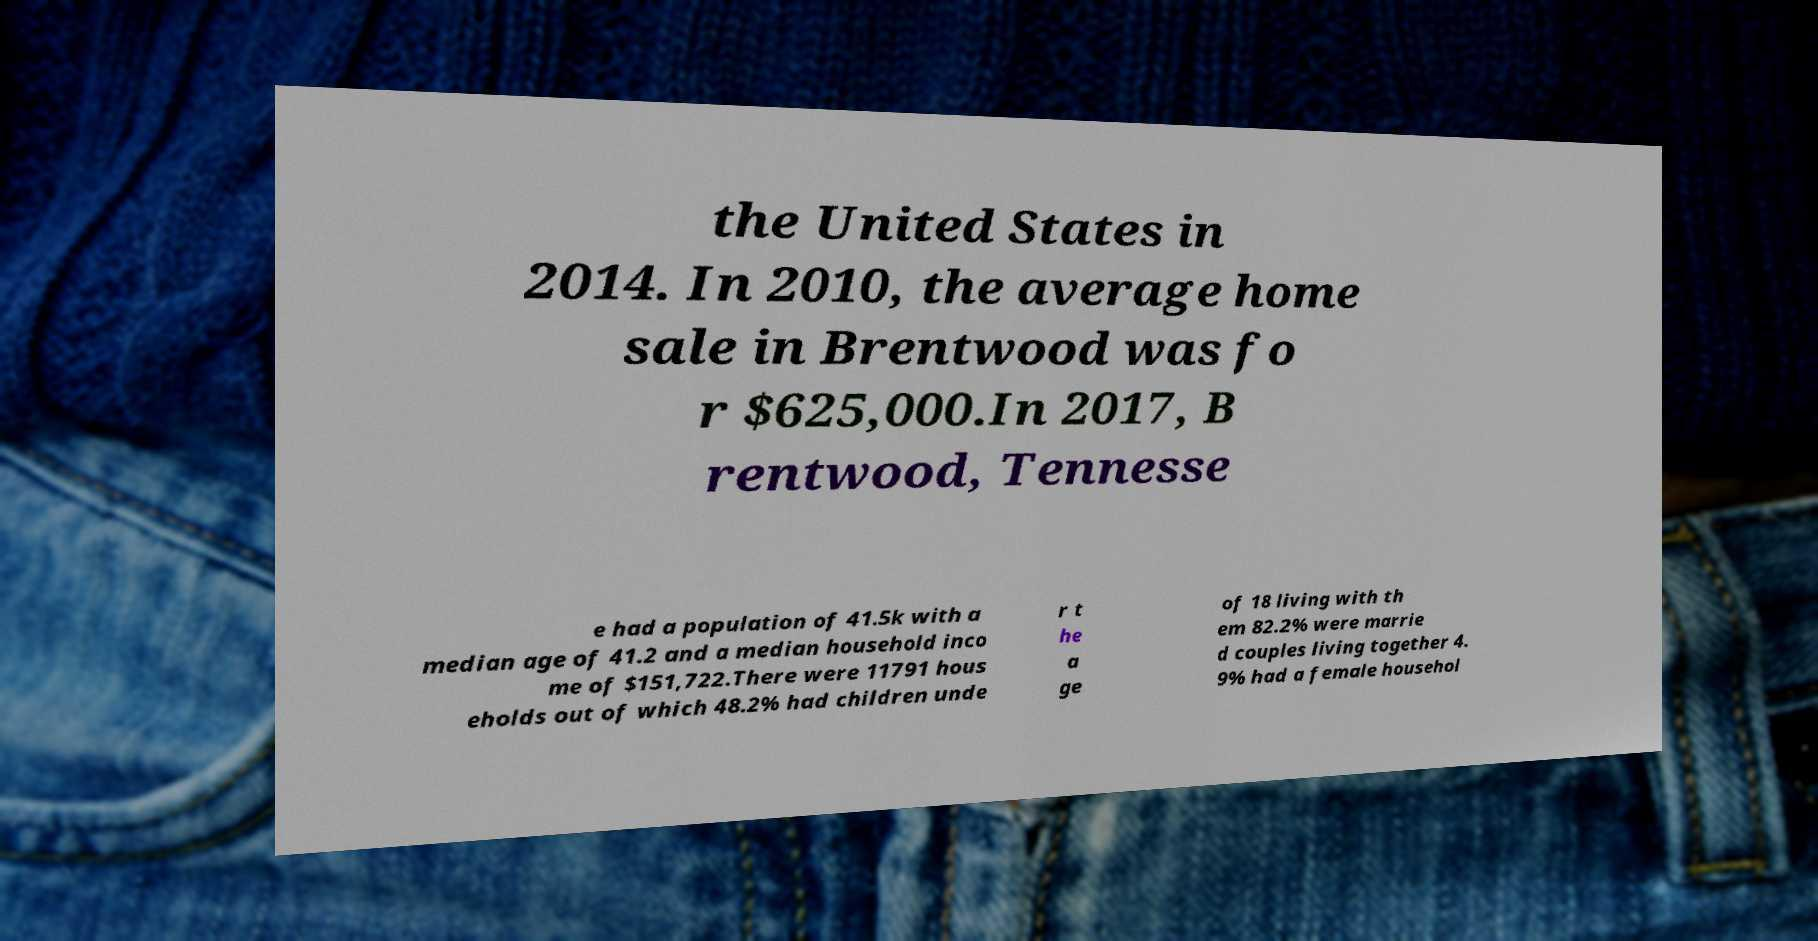Could you assist in decoding the text presented in this image and type it out clearly? the United States in 2014. In 2010, the average home sale in Brentwood was fo r $625,000.In 2017, B rentwood, Tennesse e had a population of 41.5k with a median age of 41.2 and a median household inco me of $151,722.There were 11791 hous eholds out of which 48.2% had children unde r t he a ge of 18 living with th em 82.2% were marrie d couples living together 4. 9% had a female househol 